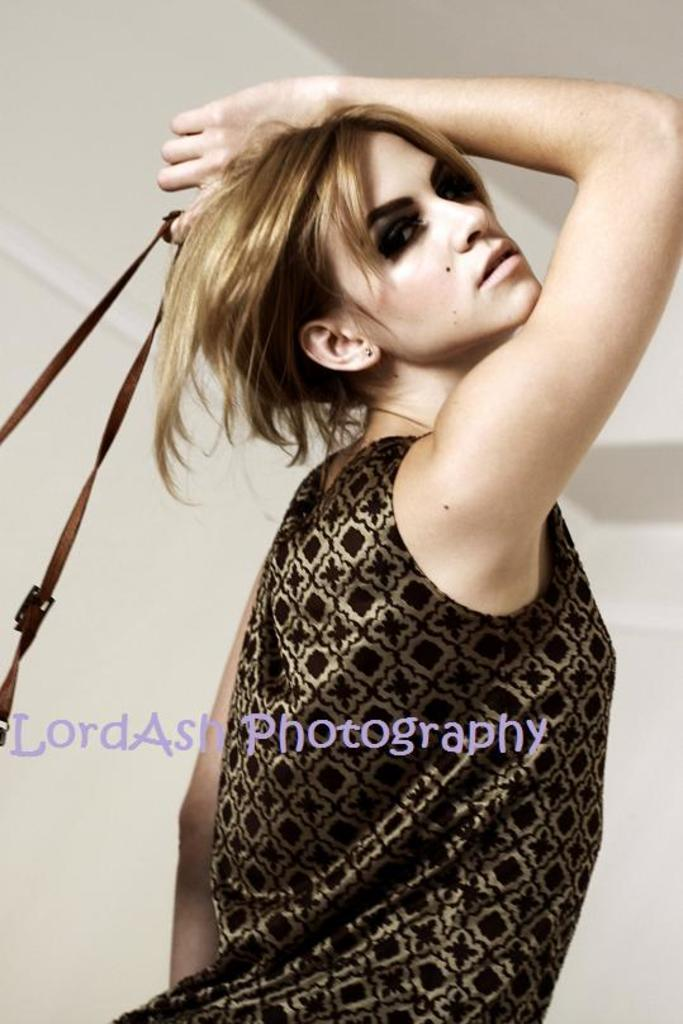Who is present in the image? There is a lady in the image. What is the lady holding in the image? The lady is holding a bag. What else can be seen in the image besides the lady? There is some text visible in the image. What is visible in the background of the image? There is a wall in the background of the image. How many trucks can be seen in the image? There are no trucks present in the image. What type of shoe is the lady wearing in the image? The image does not show the lady's shoes, so it cannot be determined what type of shoe she is wearing. 